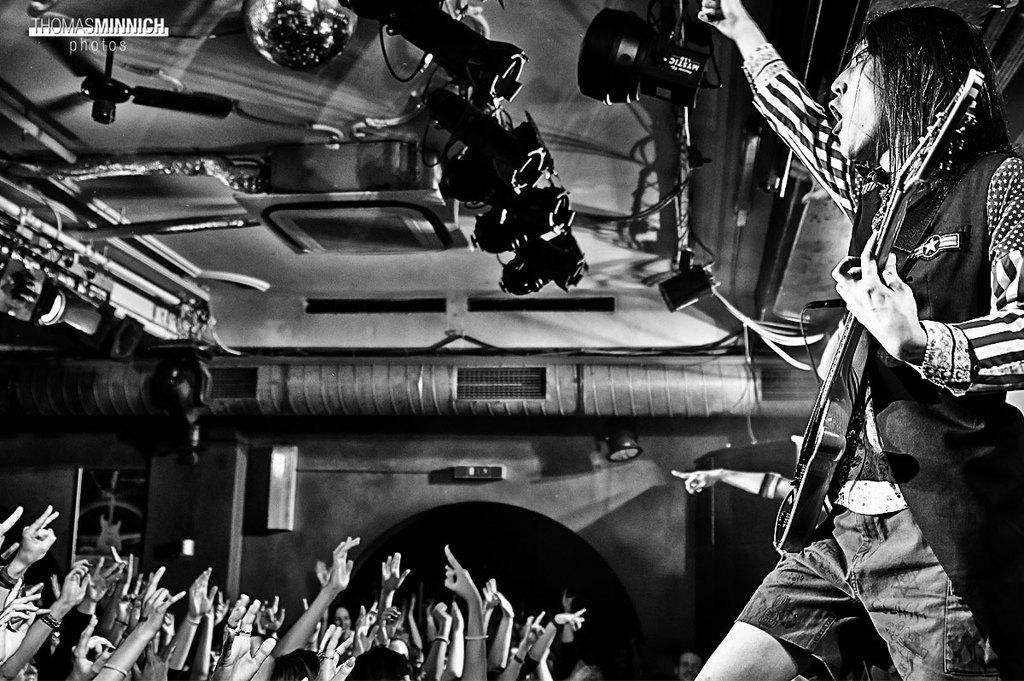What is the man in the image doing? The man is playing a guitar in the image. What object can be seen in the image that might provide air circulation? There is a fan in the image. What type of background is visible in the image? There is a wall in the image. How many people are present in the image? There are some persons in the image. What type of stream can be seen flowing in the image? There is no stream present in the image. 